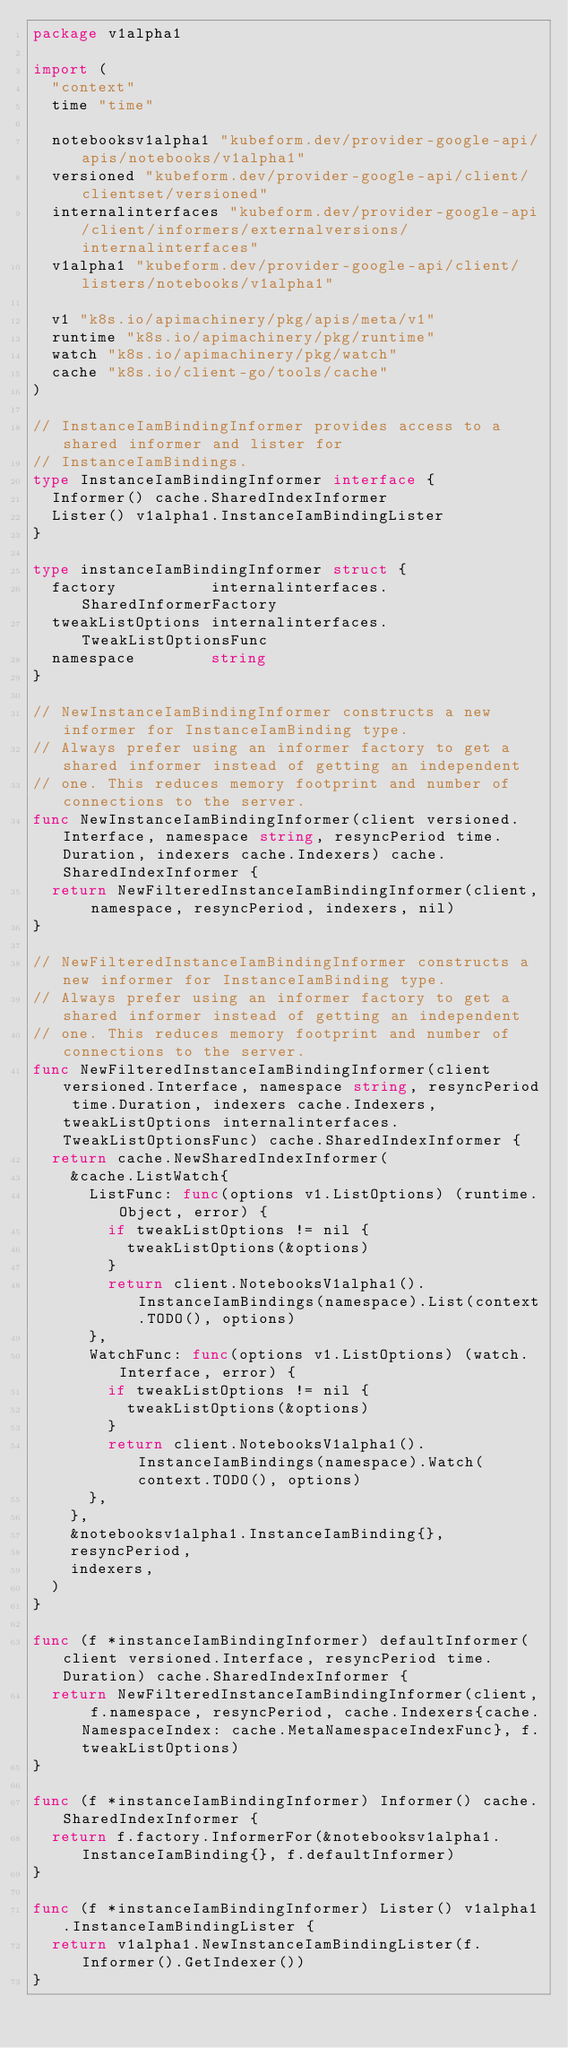<code> <loc_0><loc_0><loc_500><loc_500><_Go_>package v1alpha1

import (
	"context"
	time "time"

	notebooksv1alpha1 "kubeform.dev/provider-google-api/apis/notebooks/v1alpha1"
	versioned "kubeform.dev/provider-google-api/client/clientset/versioned"
	internalinterfaces "kubeform.dev/provider-google-api/client/informers/externalversions/internalinterfaces"
	v1alpha1 "kubeform.dev/provider-google-api/client/listers/notebooks/v1alpha1"

	v1 "k8s.io/apimachinery/pkg/apis/meta/v1"
	runtime "k8s.io/apimachinery/pkg/runtime"
	watch "k8s.io/apimachinery/pkg/watch"
	cache "k8s.io/client-go/tools/cache"
)

// InstanceIamBindingInformer provides access to a shared informer and lister for
// InstanceIamBindings.
type InstanceIamBindingInformer interface {
	Informer() cache.SharedIndexInformer
	Lister() v1alpha1.InstanceIamBindingLister
}

type instanceIamBindingInformer struct {
	factory          internalinterfaces.SharedInformerFactory
	tweakListOptions internalinterfaces.TweakListOptionsFunc
	namespace        string
}

// NewInstanceIamBindingInformer constructs a new informer for InstanceIamBinding type.
// Always prefer using an informer factory to get a shared informer instead of getting an independent
// one. This reduces memory footprint and number of connections to the server.
func NewInstanceIamBindingInformer(client versioned.Interface, namespace string, resyncPeriod time.Duration, indexers cache.Indexers) cache.SharedIndexInformer {
	return NewFilteredInstanceIamBindingInformer(client, namespace, resyncPeriod, indexers, nil)
}

// NewFilteredInstanceIamBindingInformer constructs a new informer for InstanceIamBinding type.
// Always prefer using an informer factory to get a shared informer instead of getting an independent
// one. This reduces memory footprint and number of connections to the server.
func NewFilteredInstanceIamBindingInformer(client versioned.Interface, namespace string, resyncPeriod time.Duration, indexers cache.Indexers, tweakListOptions internalinterfaces.TweakListOptionsFunc) cache.SharedIndexInformer {
	return cache.NewSharedIndexInformer(
		&cache.ListWatch{
			ListFunc: func(options v1.ListOptions) (runtime.Object, error) {
				if tweakListOptions != nil {
					tweakListOptions(&options)
				}
				return client.NotebooksV1alpha1().InstanceIamBindings(namespace).List(context.TODO(), options)
			},
			WatchFunc: func(options v1.ListOptions) (watch.Interface, error) {
				if tweakListOptions != nil {
					tweakListOptions(&options)
				}
				return client.NotebooksV1alpha1().InstanceIamBindings(namespace).Watch(context.TODO(), options)
			},
		},
		&notebooksv1alpha1.InstanceIamBinding{},
		resyncPeriod,
		indexers,
	)
}

func (f *instanceIamBindingInformer) defaultInformer(client versioned.Interface, resyncPeriod time.Duration) cache.SharedIndexInformer {
	return NewFilteredInstanceIamBindingInformer(client, f.namespace, resyncPeriod, cache.Indexers{cache.NamespaceIndex: cache.MetaNamespaceIndexFunc}, f.tweakListOptions)
}

func (f *instanceIamBindingInformer) Informer() cache.SharedIndexInformer {
	return f.factory.InformerFor(&notebooksv1alpha1.InstanceIamBinding{}, f.defaultInformer)
}

func (f *instanceIamBindingInformer) Lister() v1alpha1.InstanceIamBindingLister {
	return v1alpha1.NewInstanceIamBindingLister(f.Informer().GetIndexer())
}
</code> 